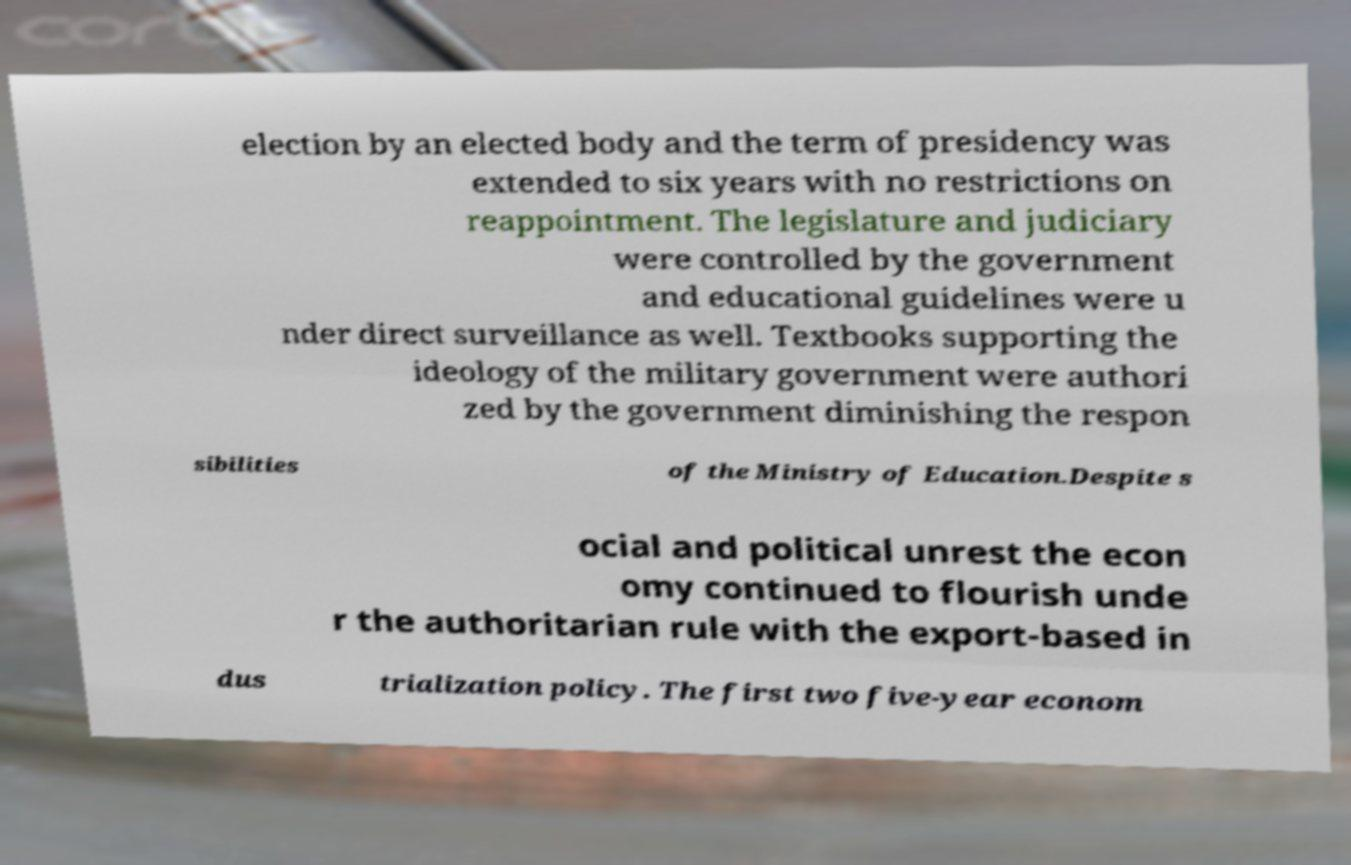I need the written content from this picture converted into text. Can you do that? election by an elected body and the term of presidency was extended to six years with no restrictions on reappointment. The legislature and judiciary were controlled by the government and educational guidelines were u nder direct surveillance as well. Textbooks supporting the ideology of the military government were authori zed by the government diminishing the respon sibilities of the Ministry of Education.Despite s ocial and political unrest the econ omy continued to flourish unde r the authoritarian rule with the export-based in dus trialization policy. The first two five-year econom 